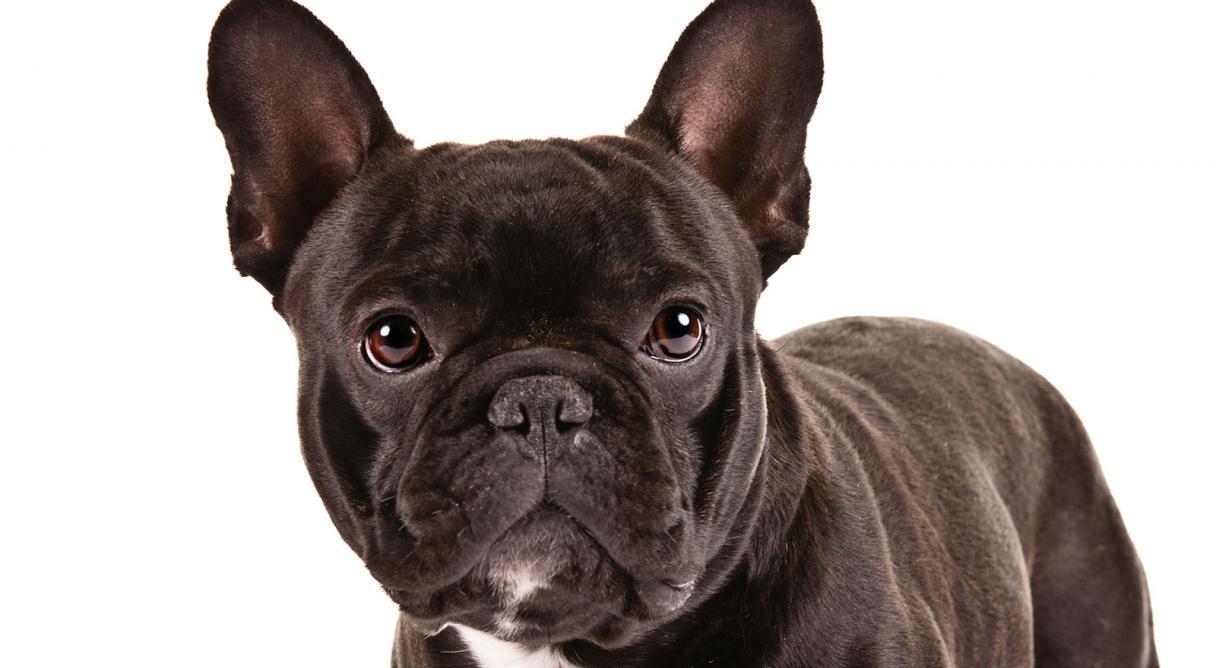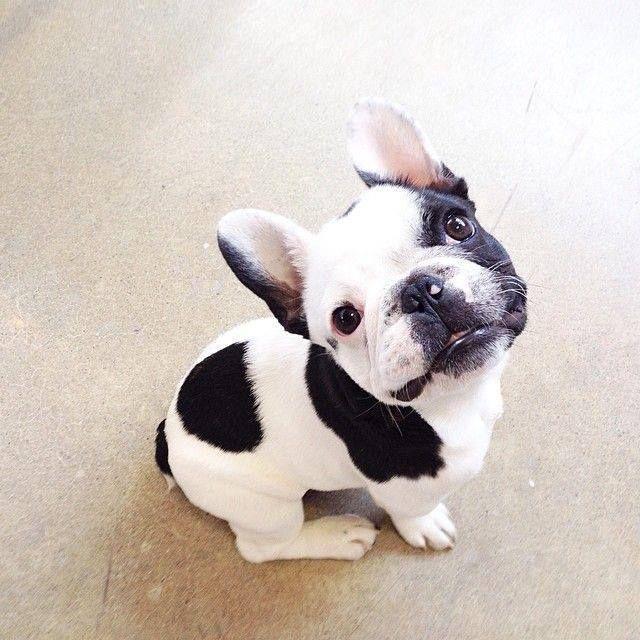The first image is the image on the left, the second image is the image on the right. For the images shown, is this caption "There are two dogs shown in total." true? Answer yes or no. Yes. The first image is the image on the left, the second image is the image on the right. For the images displayed, is the sentence "There are two dogs" factually correct? Answer yes or no. Yes. 